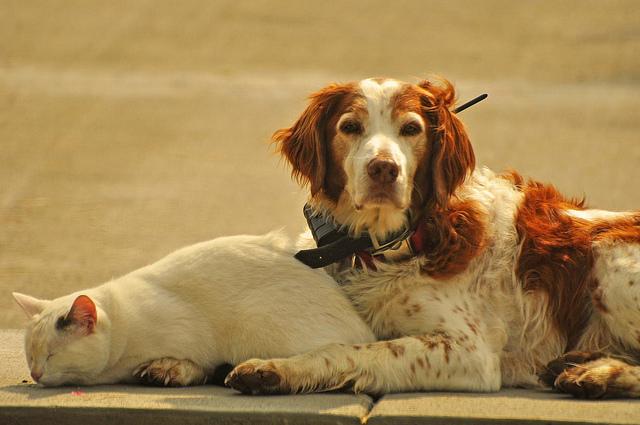How many dogs are there?
Give a very brief answer. 1. What time of day is it?
Answer briefly. Morning. Is the cat sleeping?
Keep it brief. Yes. What is the black box around the dog's neck for?
Keep it brief. Collar. 